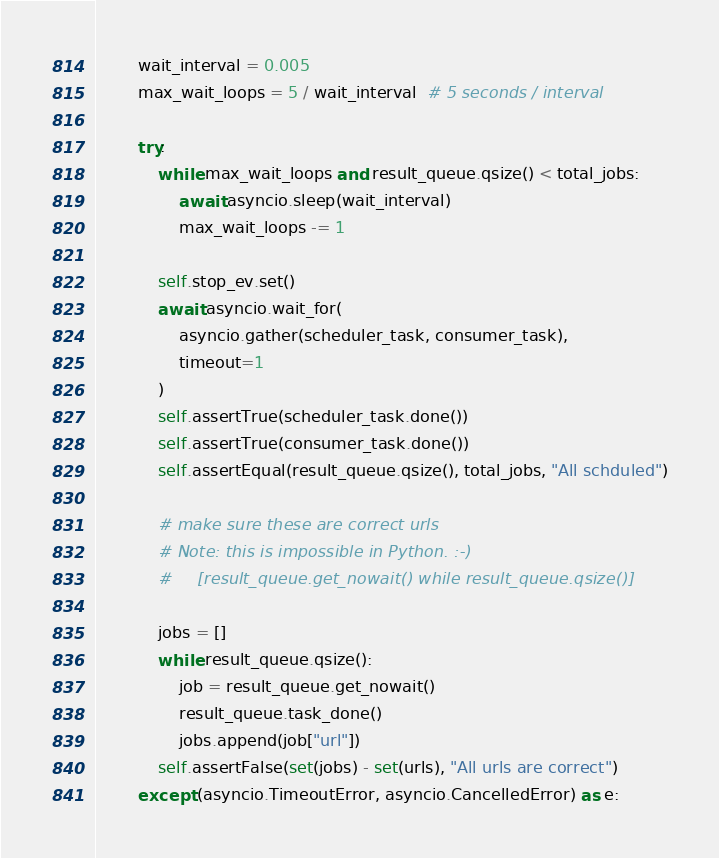Convert code to text. <code><loc_0><loc_0><loc_500><loc_500><_Python_>        wait_interval = 0.005
        max_wait_loops = 5 / wait_interval  # 5 seconds / interval

        try:
            while max_wait_loops and result_queue.qsize() < total_jobs:
                await asyncio.sleep(wait_interval)
                max_wait_loops -= 1

            self.stop_ev.set()
            await asyncio.wait_for(
                asyncio.gather(scheduler_task, consumer_task),
                timeout=1
            )
            self.assertTrue(scheduler_task.done())
            self.assertTrue(consumer_task.done())
            self.assertEqual(result_queue.qsize(), total_jobs, "All schduled")

            # make sure these are correct urls
            # Note: this is impossible in Python. :-)
            #     [result_queue.get_nowait() while result_queue.qsize()]

            jobs = []
            while result_queue.qsize():
                job = result_queue.get_nowait()
                result_queue.task_done()
                jobs.append(job["url"])
            self.assertFalse(set(jobs) - set(urls), "All urls are correct")
        except (asyncio.TimeoutError, asyncio.CancelledError) as e:</code> 